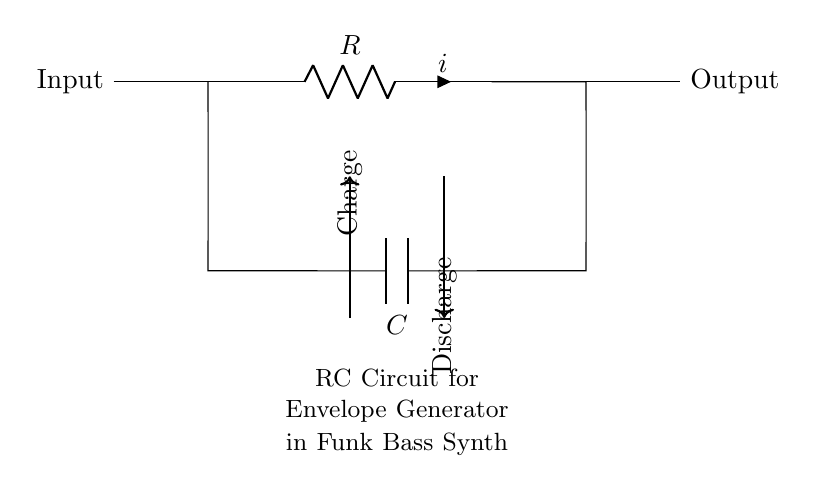What is the role of the resistor in this circuit? The resistor in an RC circuit helps to limit the current flow, which in turn affects the charging and discharging time of the capacitor. It works in connection with the capacitor to set the time constant of the circuit.
Answer: Limit current What is the component labeled "C"? The component labeled "C" represents a capacitor, which stores electrical energy in the circuit. It's essential for creating the desired envelope shape in a synth module.
Answer: Capacitor How does the capacitor charge in this circuit? The capacitor charges through the resistor when a voltage is applied at the input, allowing current to flow until the capacitor reaches a certain voltage level determined by the resistor and input voltage.
Answer: Through resistor What happens when the capacitor discharges? When the capacitor discharges, the stored energy is released back into the circuit, causing the voltage across it to drop as the current flows out through the resistor. This process can create a specific envelope effect in sound modulation.
Answer: Voltage drops What is the effect of changing the resistance value on the charging time? Increasing the resistance value will slow down the charging time of the capacitor, giving a longer time for the capacitor to reach its maximum charge, while decreasing resistance will speed up the charging time.
Answer: Slower charging What is the purpose of the envelope generator in a synth module? The envelope generator shapes the amplitude, filter cut-off, and modulation over time, impacting how the sound evolves after a note is played, crucial for funk and R&B music styles.
Answer: Shape sound What type of circuit is depicted in this diagram? The diagram depicts a first-order low-pass RC circuit, which is commonly used in synthesizer applications for creating smooth control voltage envelopes.
Answer: First-order low-pass 